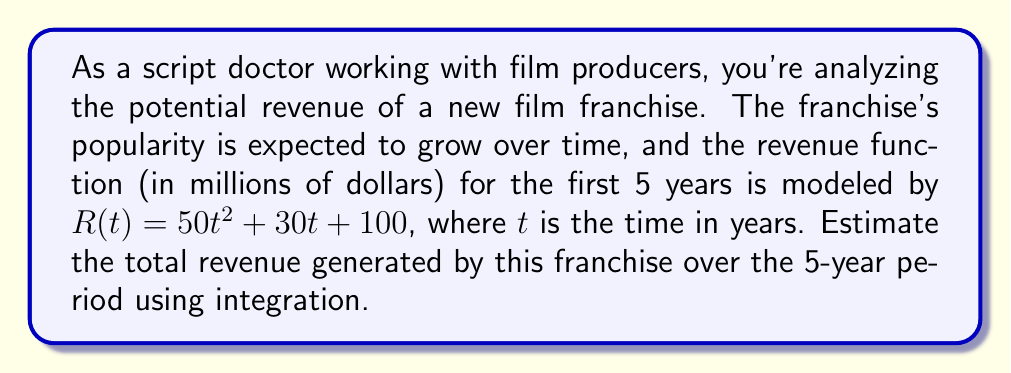Solve this math problem. To estimate the total revenue over the 5-year period, we need to calculate the definite integral of the revenue function from $t=0$ to $t=5$. This can be done using the following steps:

1. Set up the definite integral:
   $$\int_0^5 (50t^2 + 30t + 100) \, dt$$

2. Integrate the function:
   $$\left[ \frac{50t^3}{3} + 15t^2 + 100t \right]_0^5$$

3. Evaluate the integral by substituting the upper and lower bounds:
   $$\left( \frac{50(5^3)}{3} + 15(5^2) + 100(5) \right) - \left( \frac{50(0^3)}{3} + 15(0^2) + 100(0) \right)$$

4. Simplify:
   $$\left( \frac{50(125)}{3} + 15(25) + 500 \right) - 0$$
   $$= \frac{6250}{3} + 375 + 500$$
   $$= 2083.33 + 375 + 500$$
   $$= 2958.33$$

Therefore, the estimated total revenue over the 5-year period is approximately $2958.33 million.
Answer: $2958.33 million 